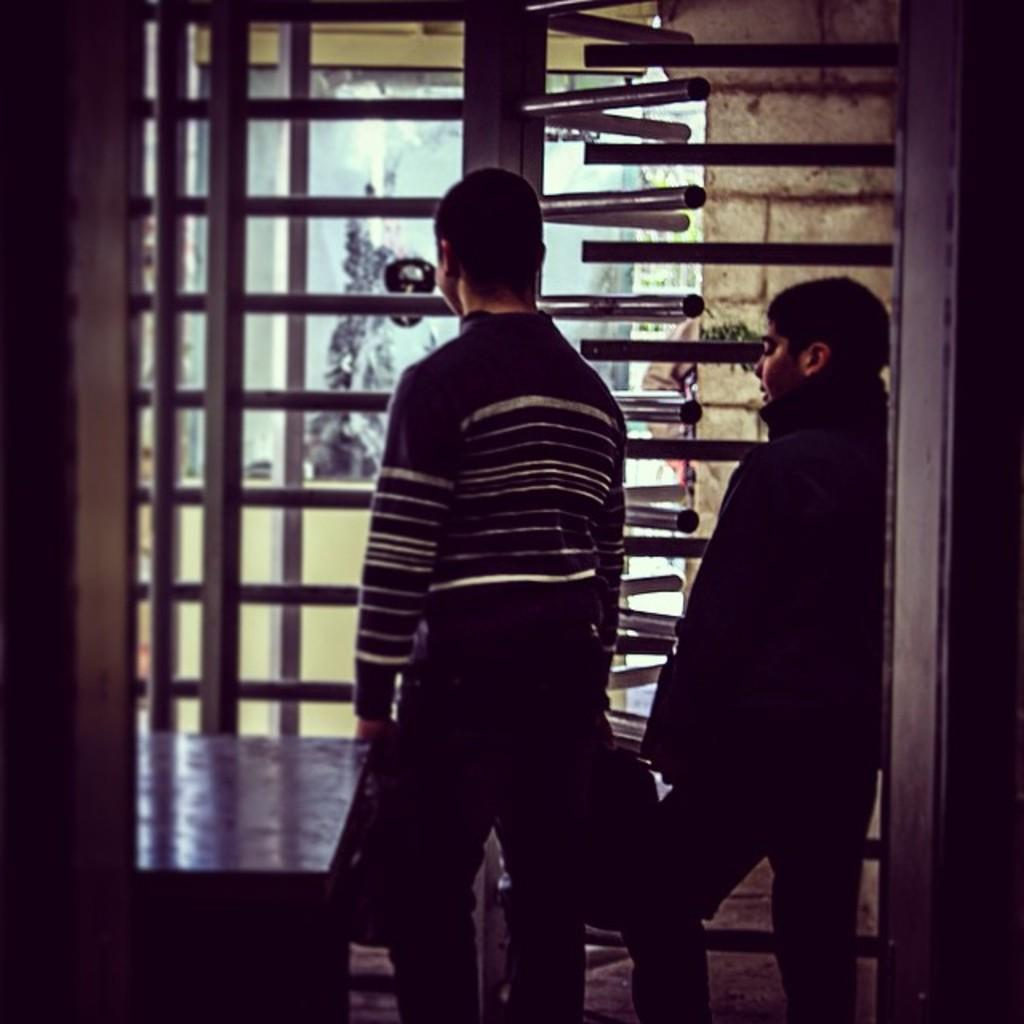Who or what can be seen in the image? There are people in the image. What objects are in front of the people? There are metal rods in front of the people. What can be seen in the distance behind the people? There are trees visible in the background of the image. What type of prose is being recited by the people in the image? There is no indication in the image that the people are reciting any prose, so it cannot be determined from the picture. 